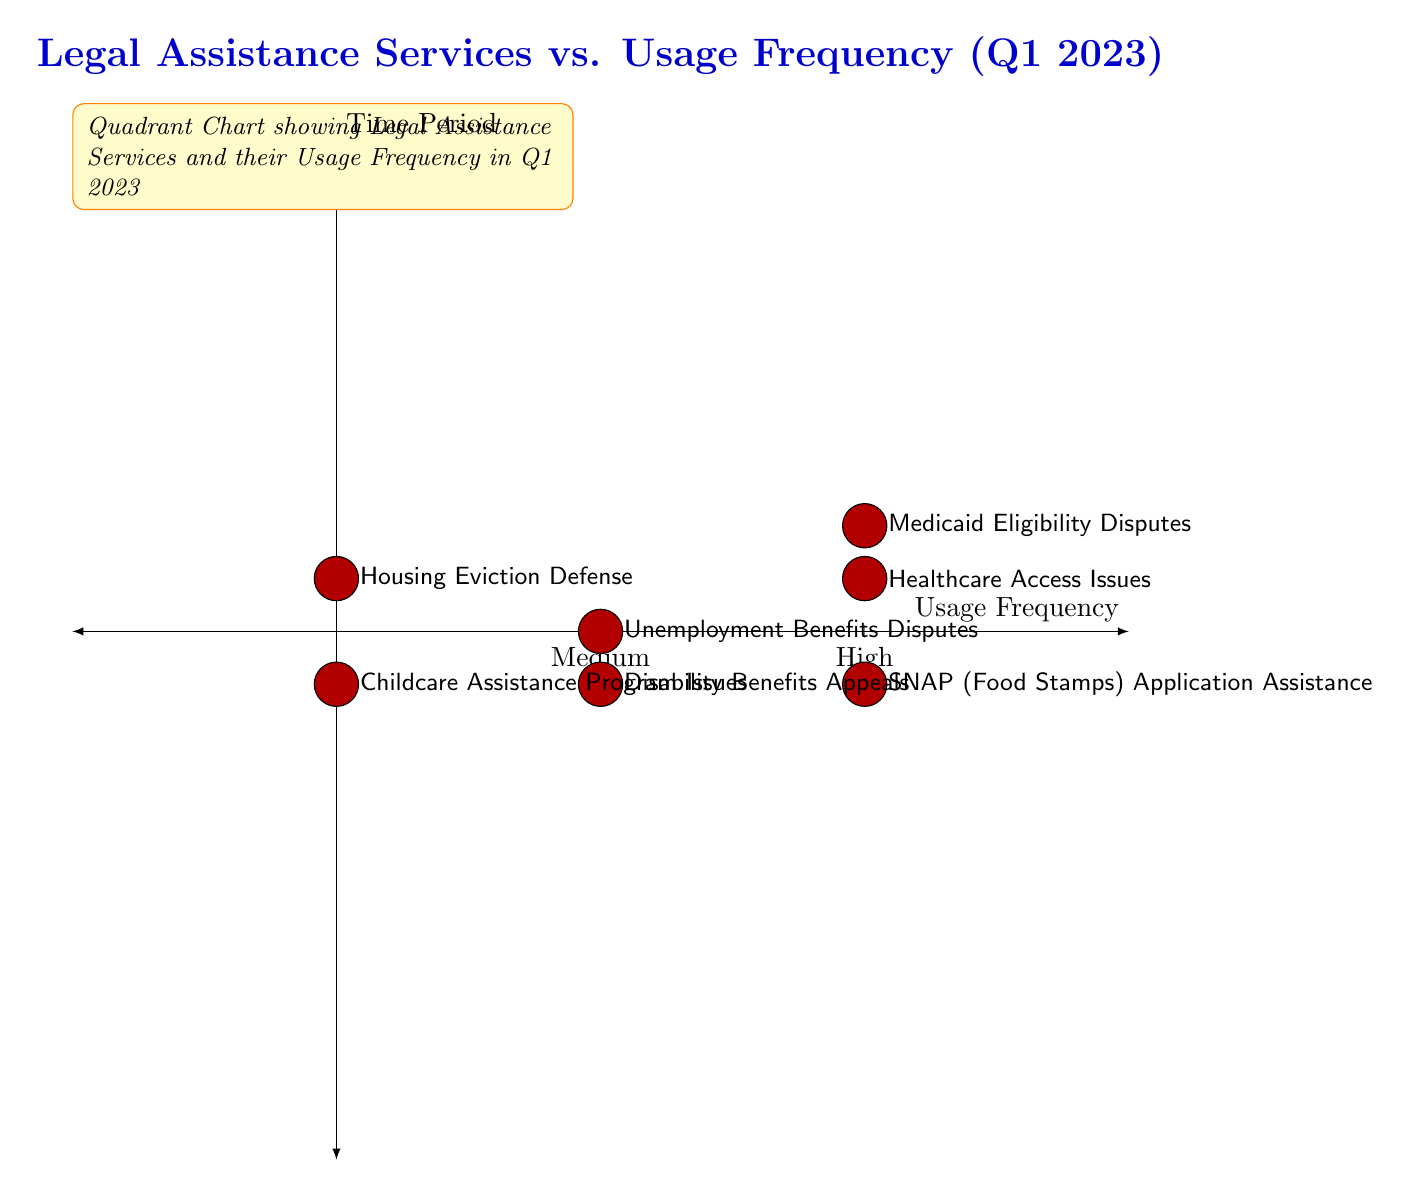What is the usage frequency of Medicaid Eligibility Disputes? The diagram places Medicaid Eligibility Disputes in the High usage frequency category, which is represented by the number 2 on the x-axis.
Answer: High How many legal assistance services have a low usage frequency? By examining the diagram, there are two services indicated on the left side (0 on the x-axis), specifically Housing Eviction Defense and Childcare Assistance Program Issues.
Answer: 2 Which legal assistance service has the highest usage frequency? The highest usage frequency is represented by the highest point on the right side of the diagram, which includes Healthcare Access Issues, SNAP Application Assistance, and Medicaid Eligibility Disputes. Thus, multiple services can be considered, but all are tagged as High.
Answer: Healthcare Access Issues, SNAP Application Assistance, Medicaid Eligibility Disputes Are there any services with a medium usage frequency? Yes, there are two services marked in the medium category (1 on the x-axis) which are Unemployment Benefits Disputes and Disability Benefits Appeals, both located in the middle of the diagram.
Answer: Yes Which service has the lowest usage frequency? The service with the lowest usage frequency is placed on the far left side of the diagram, marked as 0 on the x-axis, which corresponds to Housing Eviction Defense and Childcare Assistance Program Issues; amongst them, either can be considered appropriate.
Answer: Housing Eviction Defense How many services are represented in the diagram? Adding up all the services displayed in the diagram, there are a total of seven legal assistance services plotted based on their usage frequency.
Answer: 7 Which services have high usage frequency? The high usage frequency category captures three specific services, which are Healthcare Access Issues, SNAP Application Assistance, and Medicaid Eligibility Disputes, all marked on the right side of the diagram.
Answer: Healthcare Access Issues, SNAP Application Assistance, Medicaid Eligibility Disputes What quadrant contains the most services? The diagram shows that the High usage frequency quadrant contains the most services, specifically three services plotted, which is more than any other quadrant.
Answer: High quadrant 